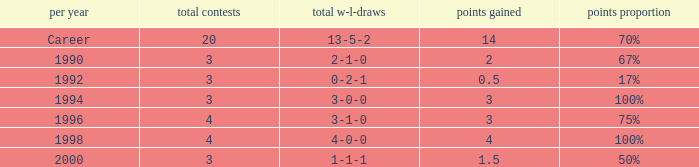Can you tell me the lowest Total natches that has the Points won of 3, and the Year of 1994? 3.0. 